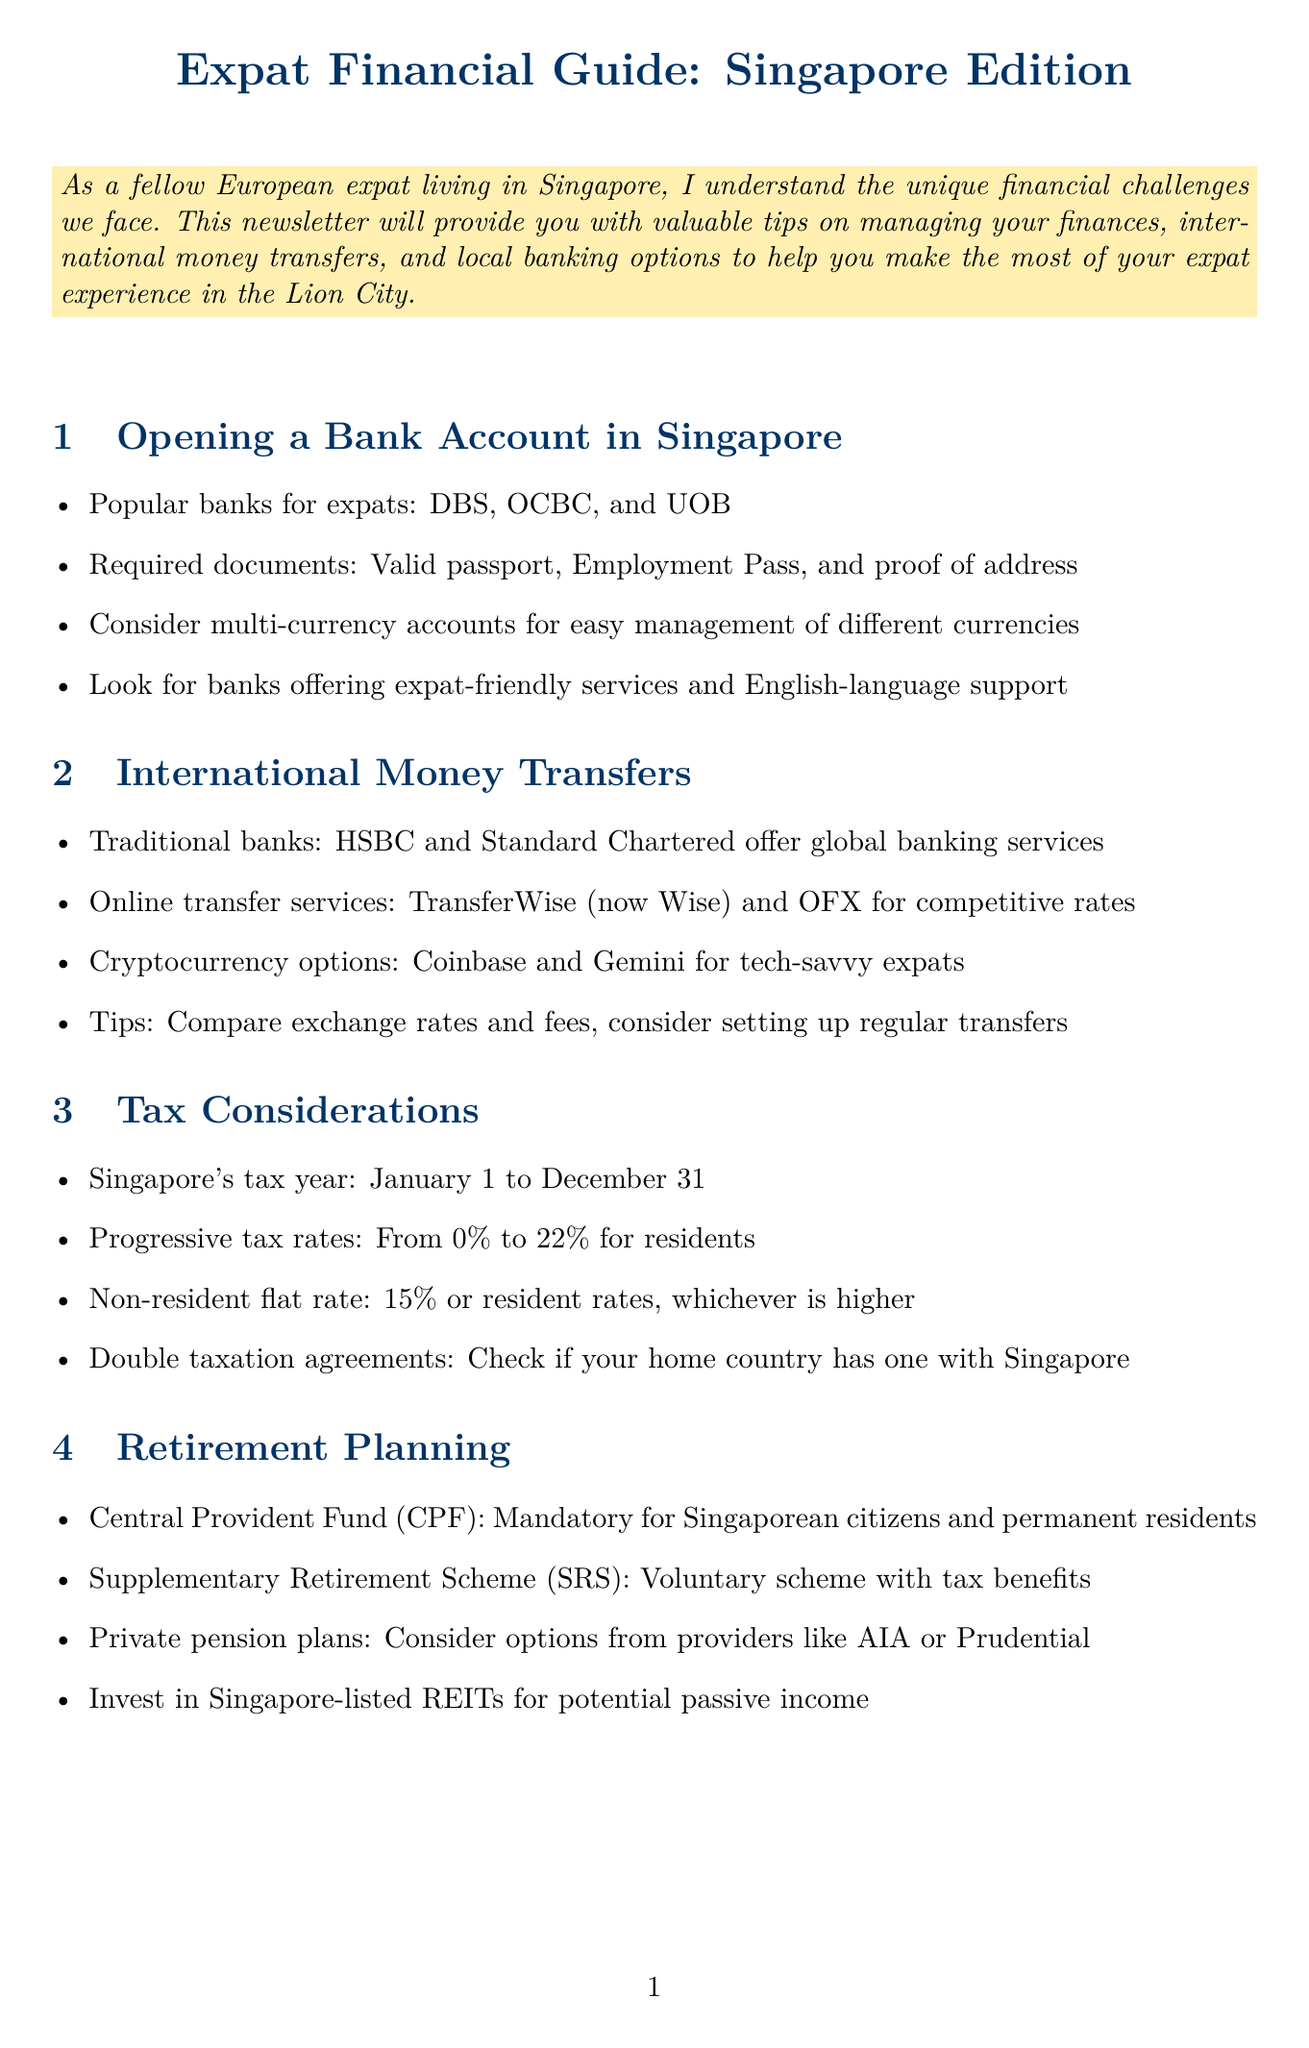what are the popular banks for expats? The document lists DBS, OCBC, and UOB as popular banks for expats.
Answer: DBS, OCBC, UOB what is required to open a bank account? The document states that a valid passport, Employment Pass, and proof of address are required documents.
Answer: Valid passport, Employment Pass, proof of address which online transfer service is mentioned for competitive rates? The document mentions TransferWise (now Wise) as an online transfer service with competitive rates.
Answer: TransferWise (now Wise) what is Singapore's tax year? The document specifies that Singapore's tax year runs from January 1 to December 31.
Answer: January 1 to December 31 what percentage are Singapore's progressive tax rates for residents? The document states that the progressive tax rates for residents range from 0% to 22%.
Answer: 0% to 22% which insurance is considered essential for frequent trips back to Europe? The document mentions that travel insurance is essential for frequent trips back to Europe.
Answer: Travel insurance what is the suggested maintenance for an emergency fund? The document suggests maintaining 3-6 months of expenses in a high-yield savings account.
Answer: 3-6 months of expenses name one robo-advisor mentioned for automated investing. The document lists StashAway as one of the robo-advisors mentioned for automated investing.
Answer: StashAway what should you utilize to save on commuting costs? The document recommends utilizing an EZ-Link card to save on commuting costs.
Answer: EZ-Link card 